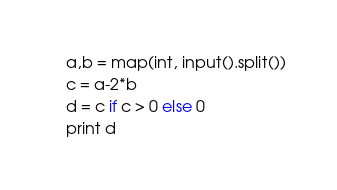<code> <loc_0><loc_0><loc_500><loc_500><_Python_>a,b = map(int, input().split())
c = a-2*b
d = c if c > 0 else 0
print d
</code> 